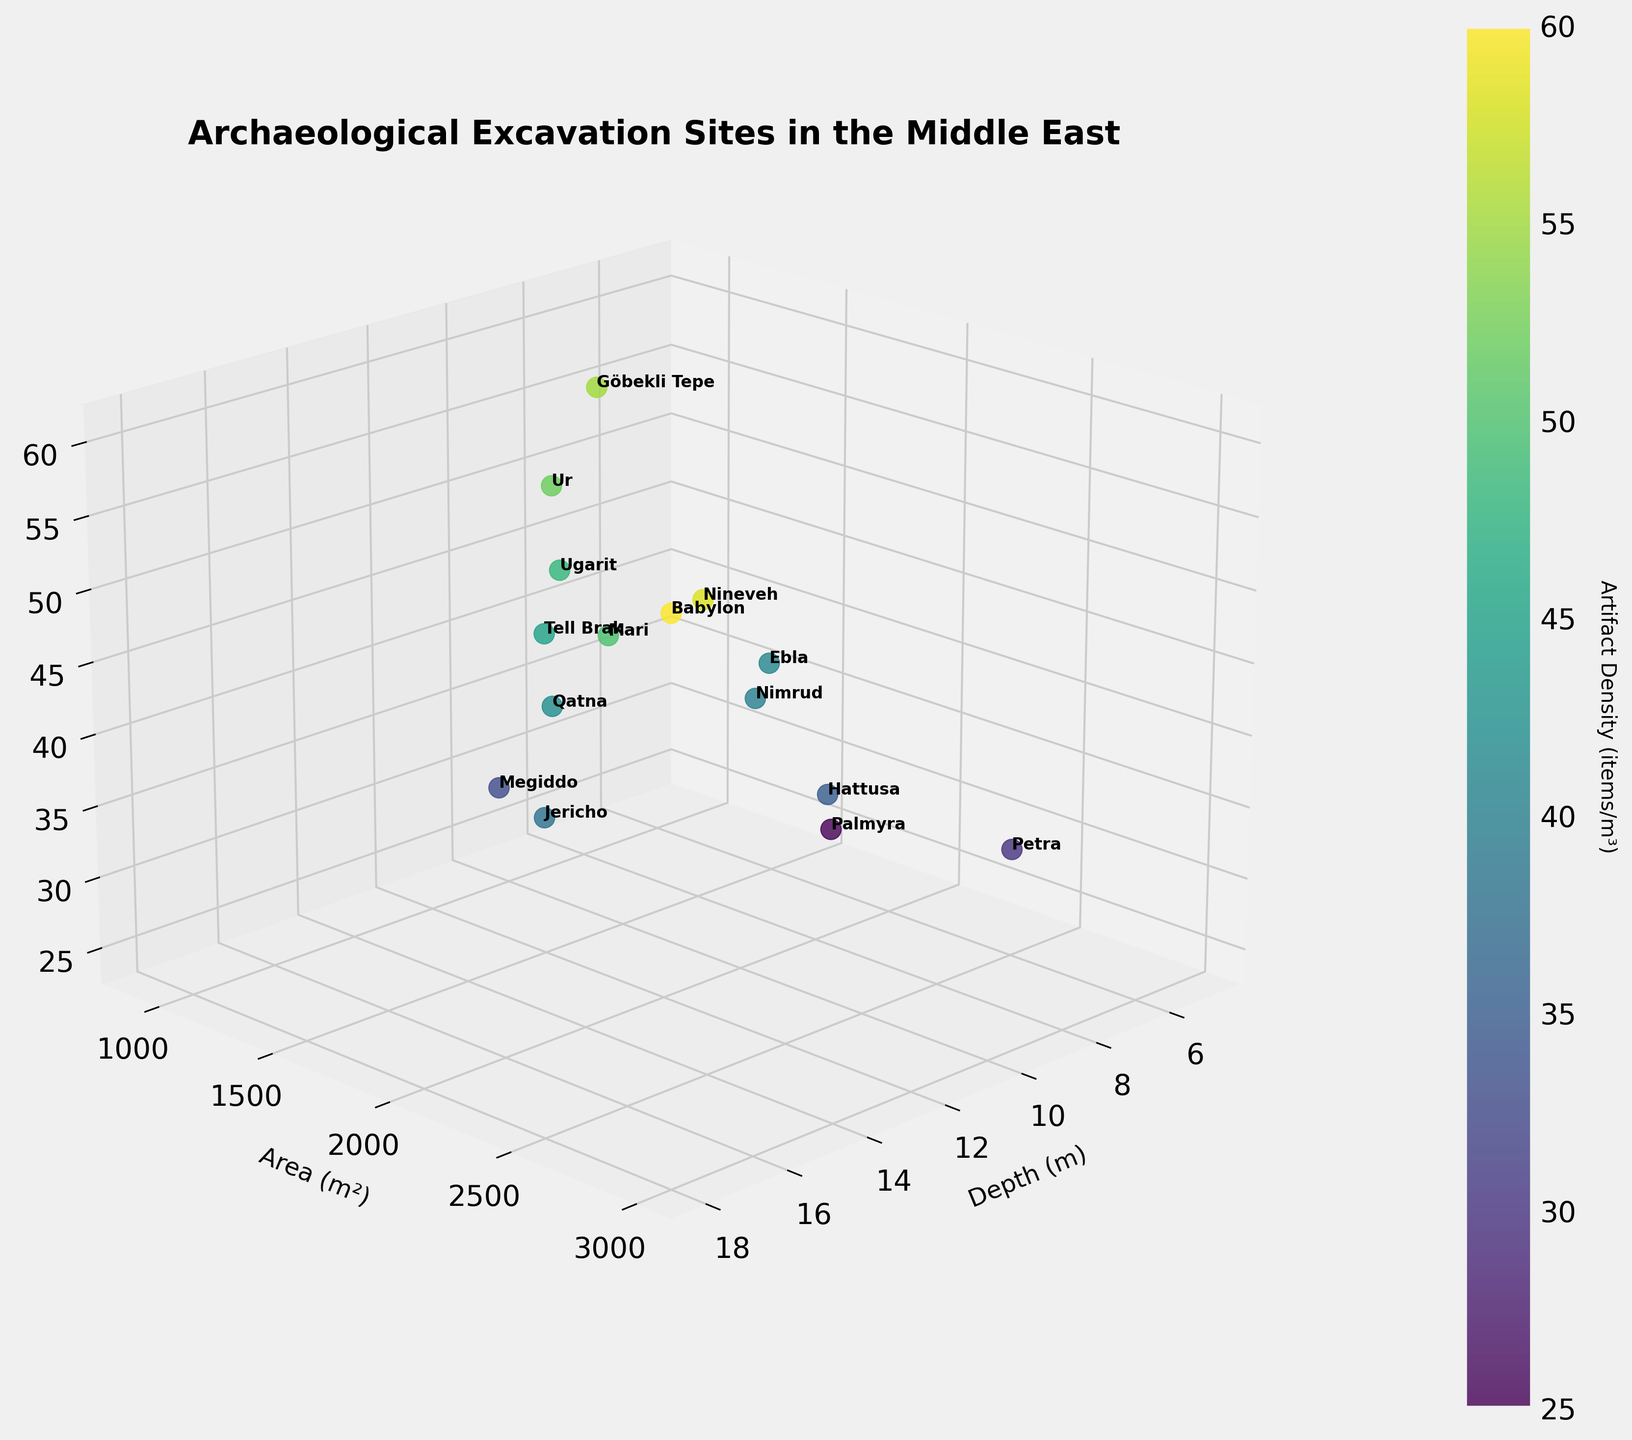Which site has the deepest excavation depth? Look at the figure and locate the site with the highest value on the Depth (m) axis. Babylon is positioned at 18 meters, making it the deepest.
Answer: Babylon What is the artifact density of the site with the largest excavation area? Look at the figure and find the site with the highest value on the Area (m²) axis. This site is Babylon with 3000 m². The Artifact Density for Babylon is 60 items/m³.
Answer: 60 items/m³ Which sites have a depth of less than 10 meters? Look at the figure and identify sites with Depth (m) values below 10. Petra (6m), Palmyra (5m), Göbekli Tepe (7m), and Ebla (8m) are all under 10 meters in depth.
Answer: Petra, Palmyra, Göbekli Tepe, Ebla How does the artifact density of Nineveh compare to Tell Brak? Find Nineveh and Tell Brak on the Depth (m) axis and compare their respective Artifact Density (items/m³) values. Nineveh has an artifact density of 58 items/m³, while Tell Brak has 45 items/m³.
Answer: Nineveh has a higher artifact density What is the average area size for sites with an artifact density above 50 items/m³? Identify sites with artifact densities above 50 (Ur, Babylon, Göbekli Tepe, Mari, Nineveh) and sum their areas (1200m² + 3000m² + 900m² + 2100m² + 2800m² = 10000m²). Then, divide by the number of sites, 10000/5 gives an average area of 2000m².
Answer: 2000 m² Which site has the highest artifact density at a depth of exactly 12 meters? From the figure, identify the sites with a depth of 12 meters. There is only one site, Tell Brak, and its artifact density is 45 items/m³.
Answer: Tell Brak Are there any sites with an excavation depth that is an outlier compared to others? Examine the Depth (m) values in the figure. Most depths range between 5-16 meters. Babylon, at 18 meters, appears to be an outlier.
Answer: Babylon What is the total number of sites plotted in the 3D chart? Count the number of unique points or labels in the plot. There are 15 distinct sites plotted.
Answer: 15 sites 